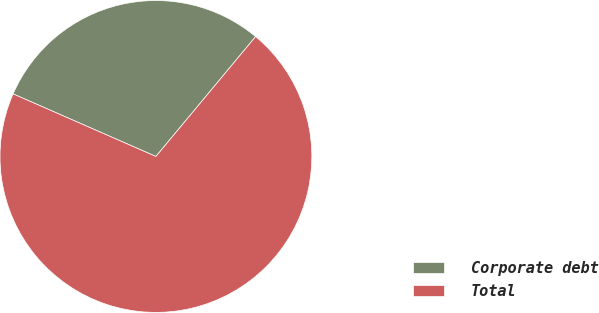Convert chart to OTSL. <chart><loc_0><loc_0><loc_500><loc_500><pie_chart><fcel>Corporate debt<fcel>Total<nl><fcel>29.47%<fcel>70.53%<nl></chart> 